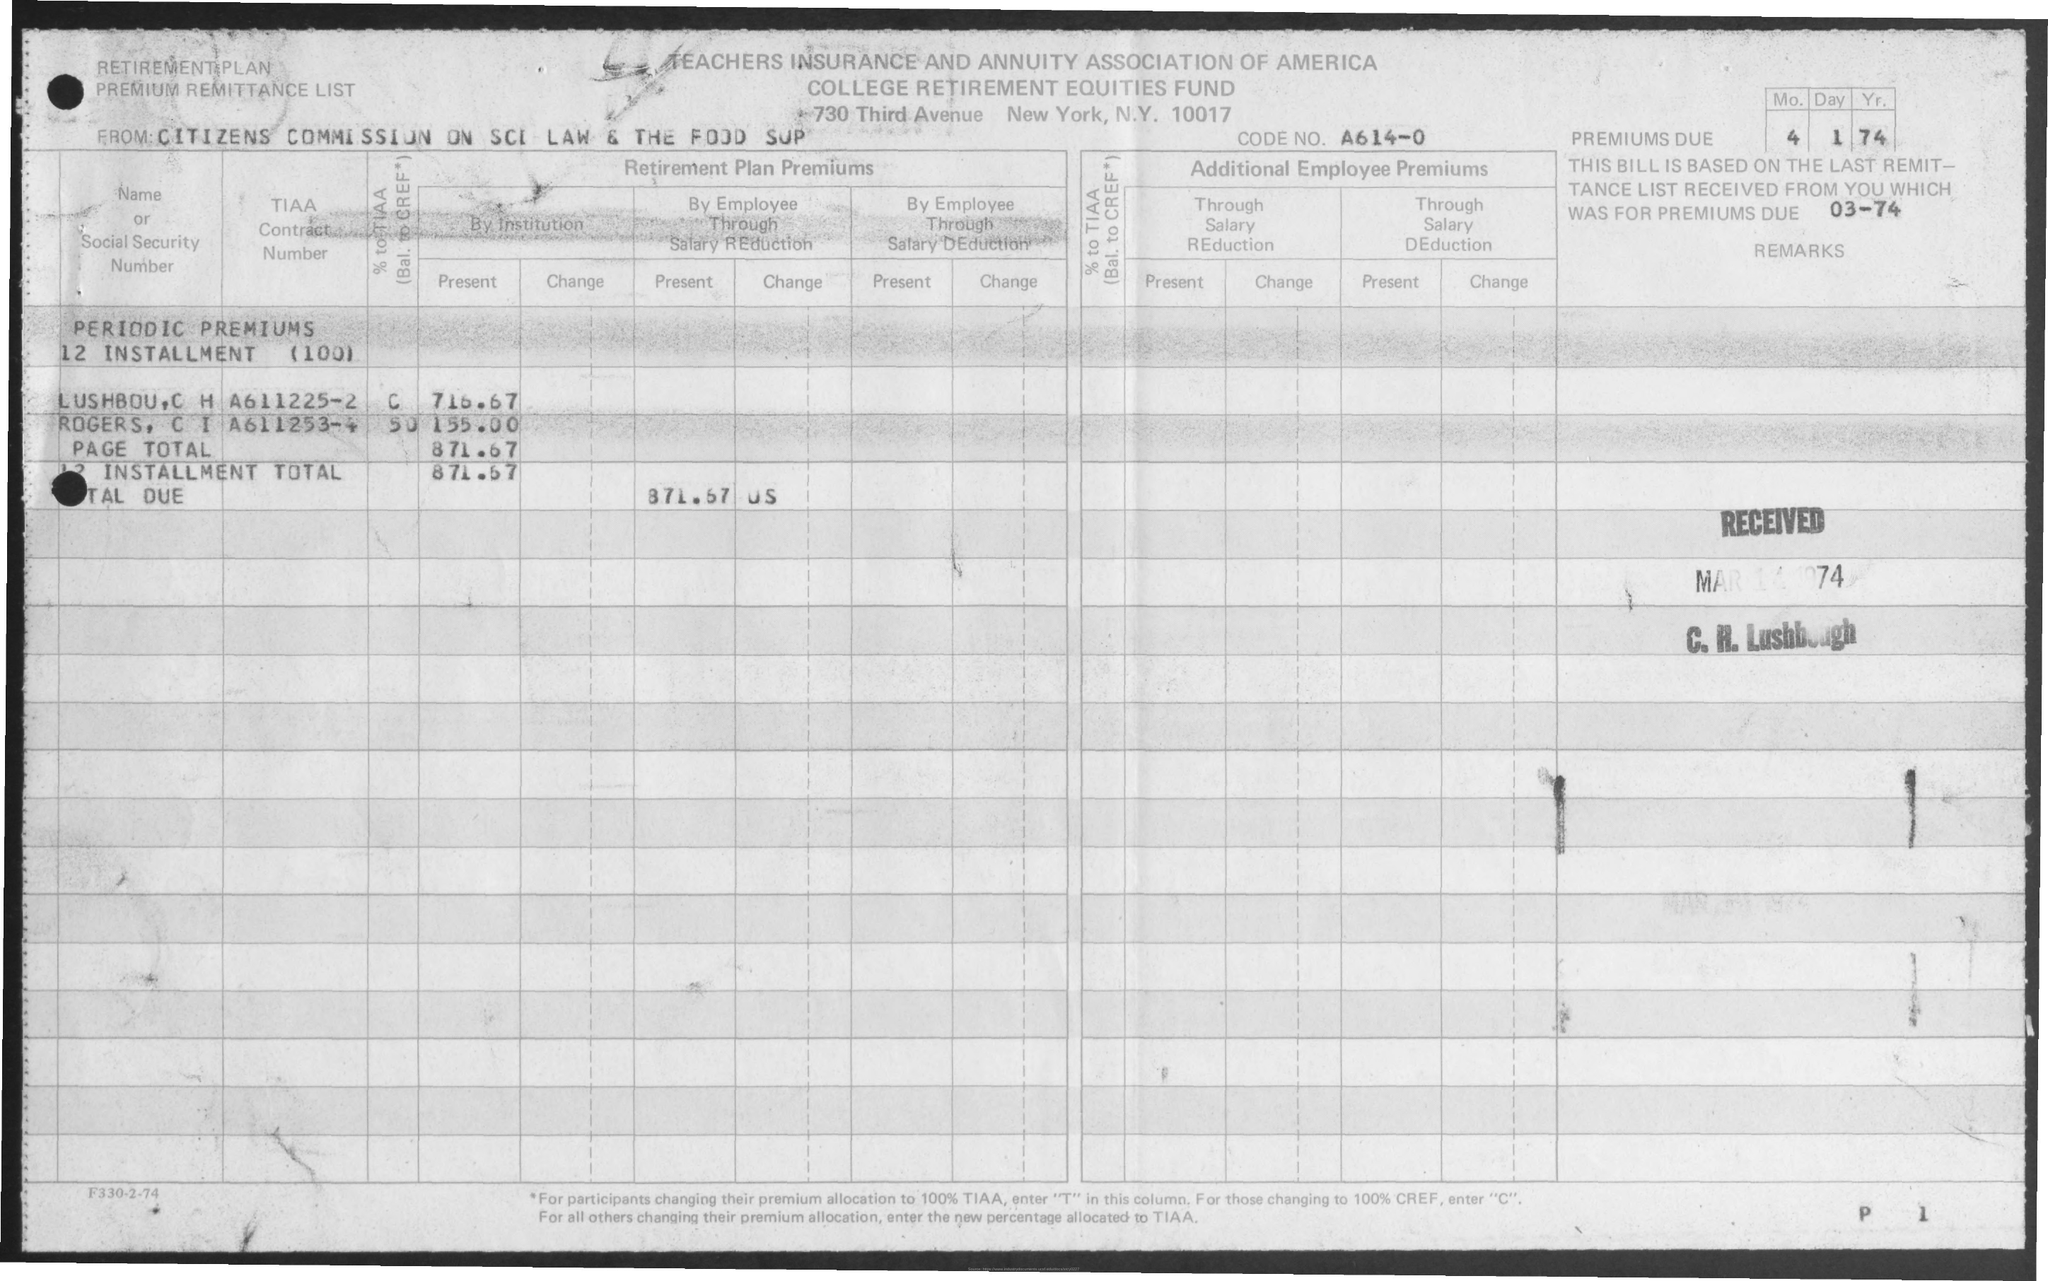Highlight a few significant elements in this photo. The form comes from the Citizens Commission on Science and Law, along with the Food Supply. The premiums are due on April 1, 1974. The code number is A614-0. 